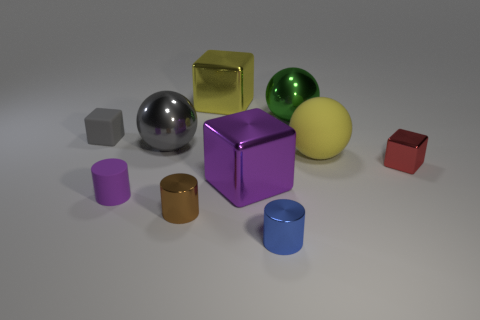Subtract all shiny balls. How many balls are left? 1 Subtract all gray blocks. How many blocks are left? 3 Subtract 1 cylinders. How many cylinders are left? 2 Subtract all cyan blocks. Subtract all brown balls. How many blocks are left? 4 Subtract all brown cylinders. Subtract all tiny things. How many objects are left? 4 Add 9 brown metallic cylinders. How many brown metallic cylinders are left? 10 Add 1 big gray spheres. How many big gray spheres exist? 2 Subtract 1 blue cylinders. How many objects are left? 9 Subtract all spheres. How many objects are left? 7 